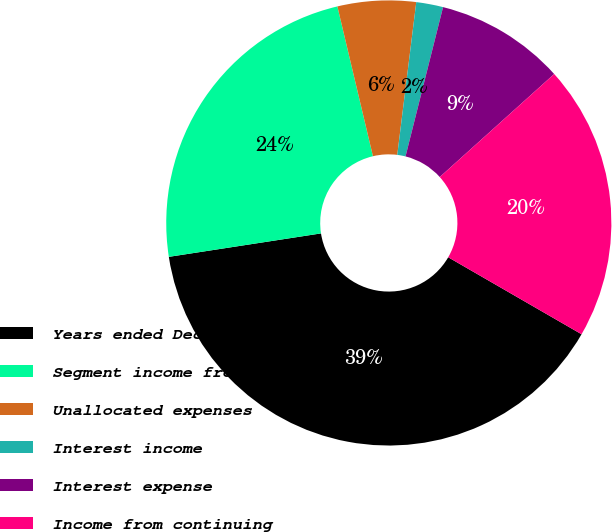<chart> <loc_0><loc_0><loc_500><loc_500><pie_chart><fcel>Years ended December 31<fcel>Segment income from continuing<fcel>Unallocated expenses<fcel>Interest income<fcel>Interest expense<fcel>Income from continuing<nl><fcel>39.23%<fcel>23.72%<fcel>5.68%<fcel>1.95%<fcel>9.41%<fcel>20.0%<nl></chart> 